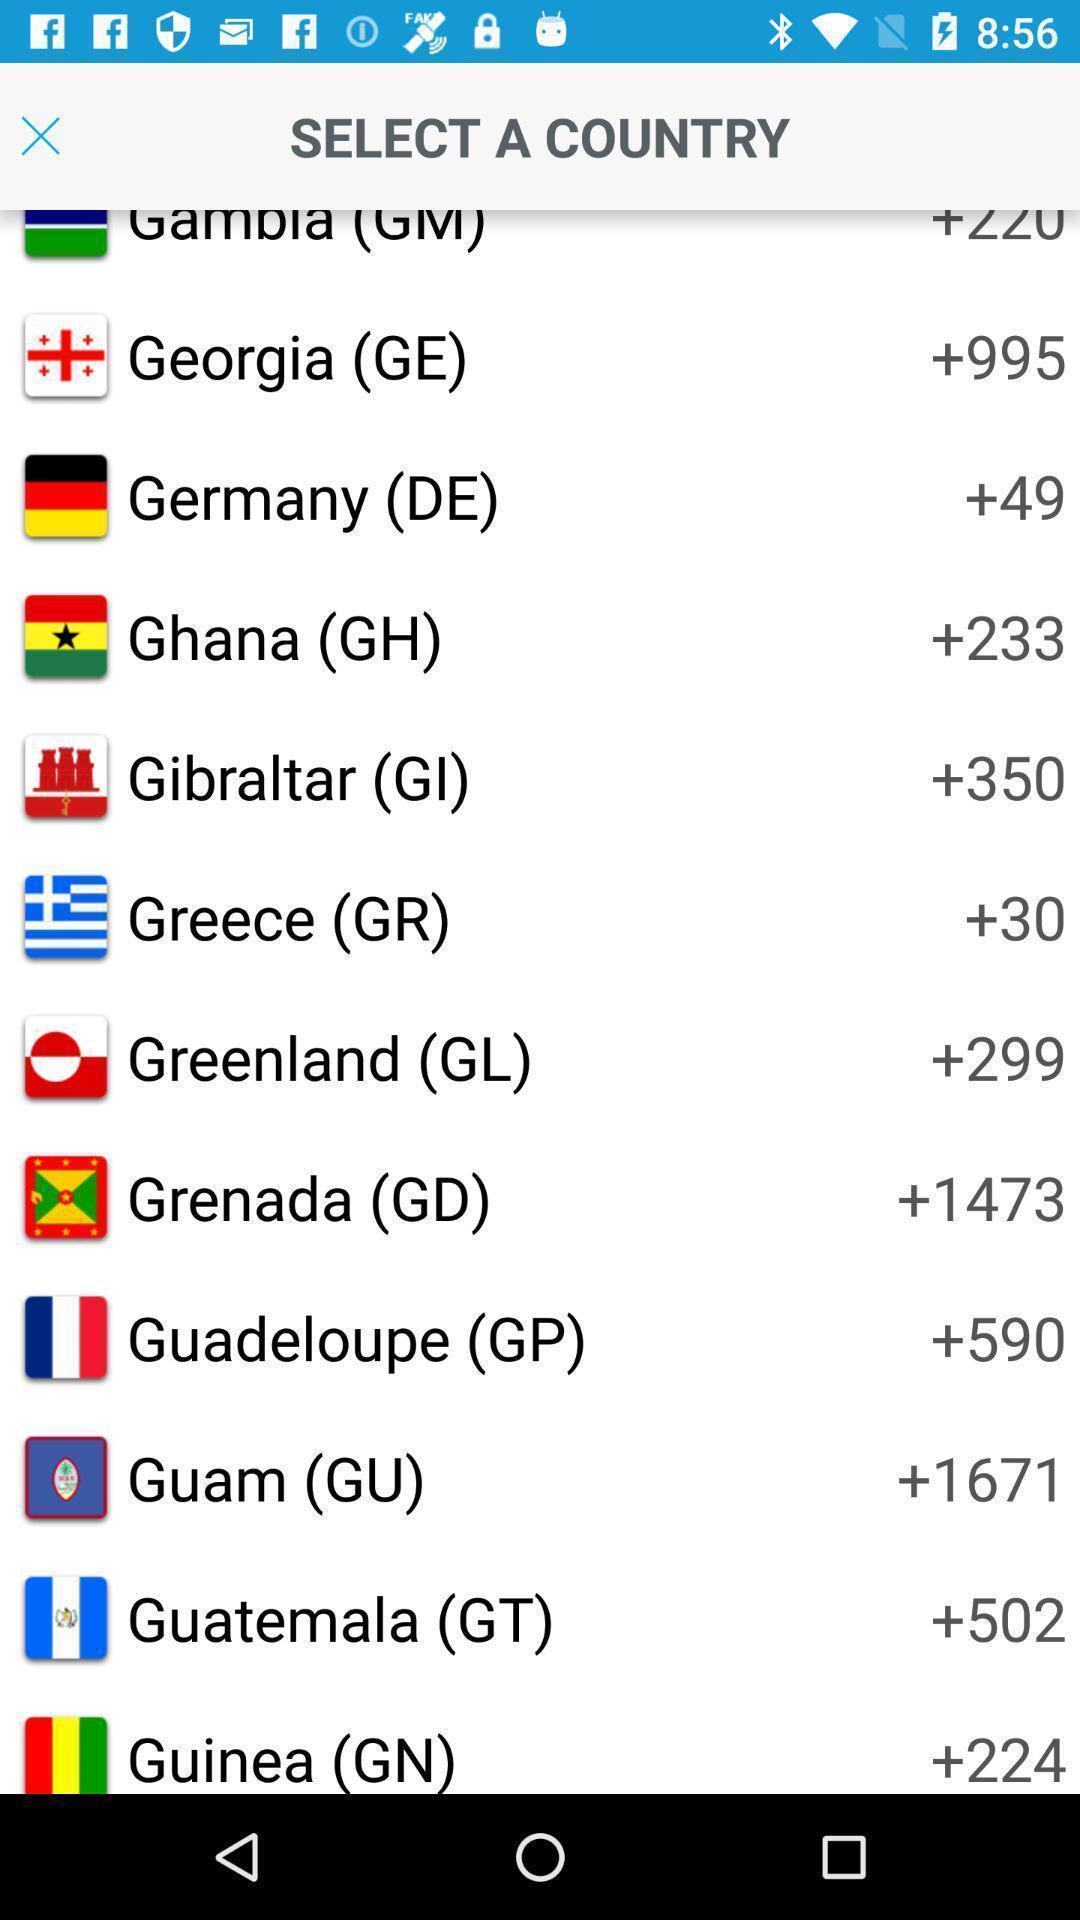Describe the content in this image. Various countries list displayed for confirmation. 